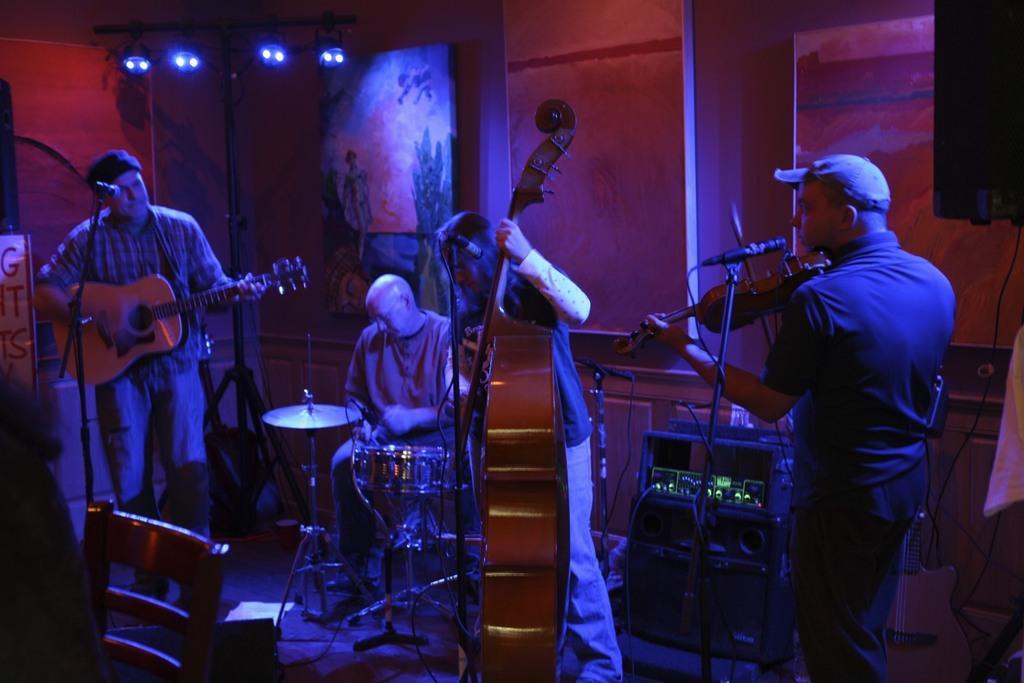How would you summarize this image in a sentence or two? On the right a person is holding violin and playing, wearing a cap. In the center a person is holding very big violin and playing. On the left a person is holding guitar and playing. In the back a person is sitting and playing drums. There is chair. In the back it is a red wall and there are lights. Also there are mic stands. 